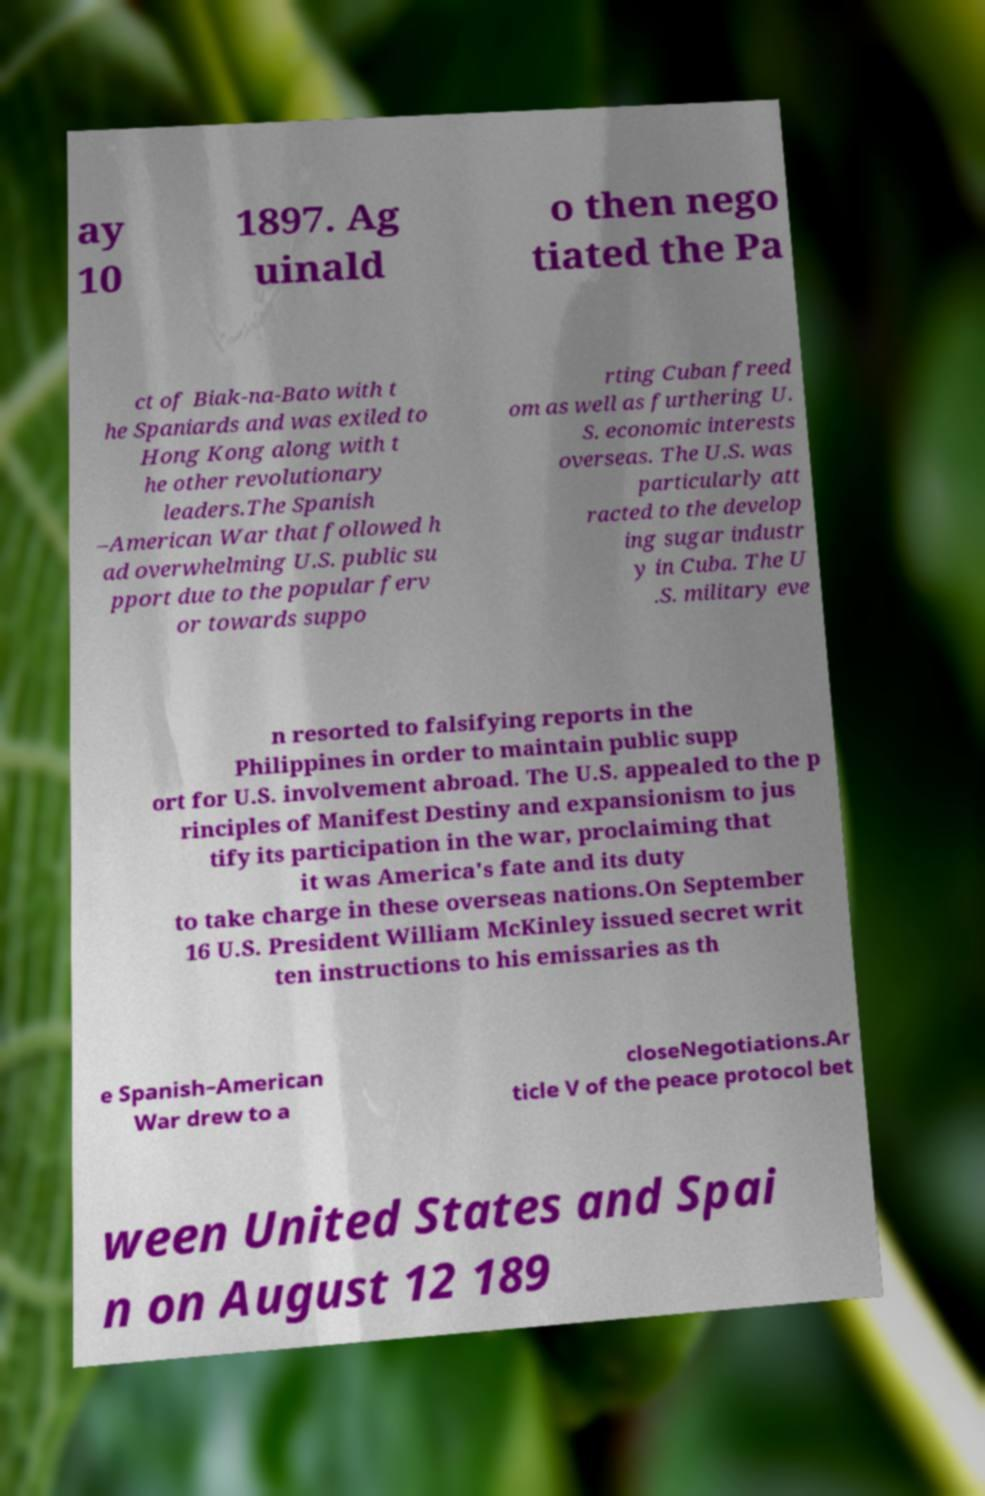Could you assist in decoding the text presented in this image and type it out clearly? ay 10 1897. Ag uinald o then nego tiated the Pa ct of Biak-na-Bato with t he Spaniards and was exiled to Hong Kong along with t he other revolutionary leaders.The Spanish –American War that followed h ad overwhelming U.S. public su pport due to the popular ferv or towards suppo rting Cuban freed om as well as furthering U. S. economic interests overseas. The U.S. was particularly att racted to the develop ing sugar industr y in Cuba. The U .S. military eve n resorted to falsifying reports in the Philippines in order to maintain public supp ort for U.S. involvement abroad. The U.S. appealed to the p rinciples of Manifest Destiny and expansionism to jus tify its participation in the war, proclaiming that it was America's fate and its duty to take charge in these overseas nations.On September 16 U.S. President William McKinley issued secret writ ten instructions to his emissaries as th e Spanish–American War drew to a closeNegotiations.Ar ticle V of the peace protocol bet ween United States and Spai n on August 12 189 